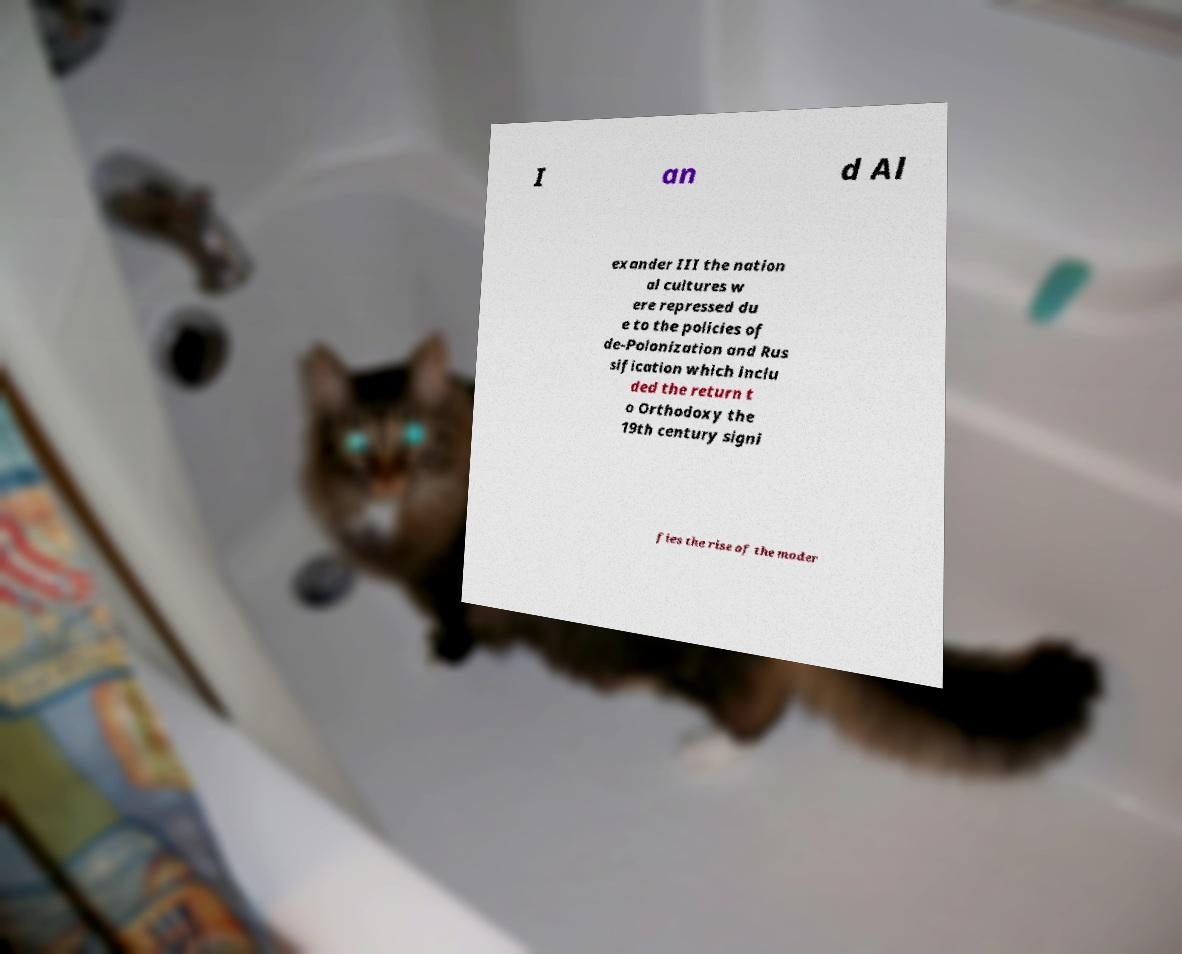Can you read and provide the text displayed in the image?This photo seems to have some interesting text. Can you extract and type it out for me? I an d Al exander III the nation al cultures w ere repressed du e to the policies of de-Polonization and Rus sification which inclu ded the return t o Orthodoxy the 19th century signi fies the rise of the moder 